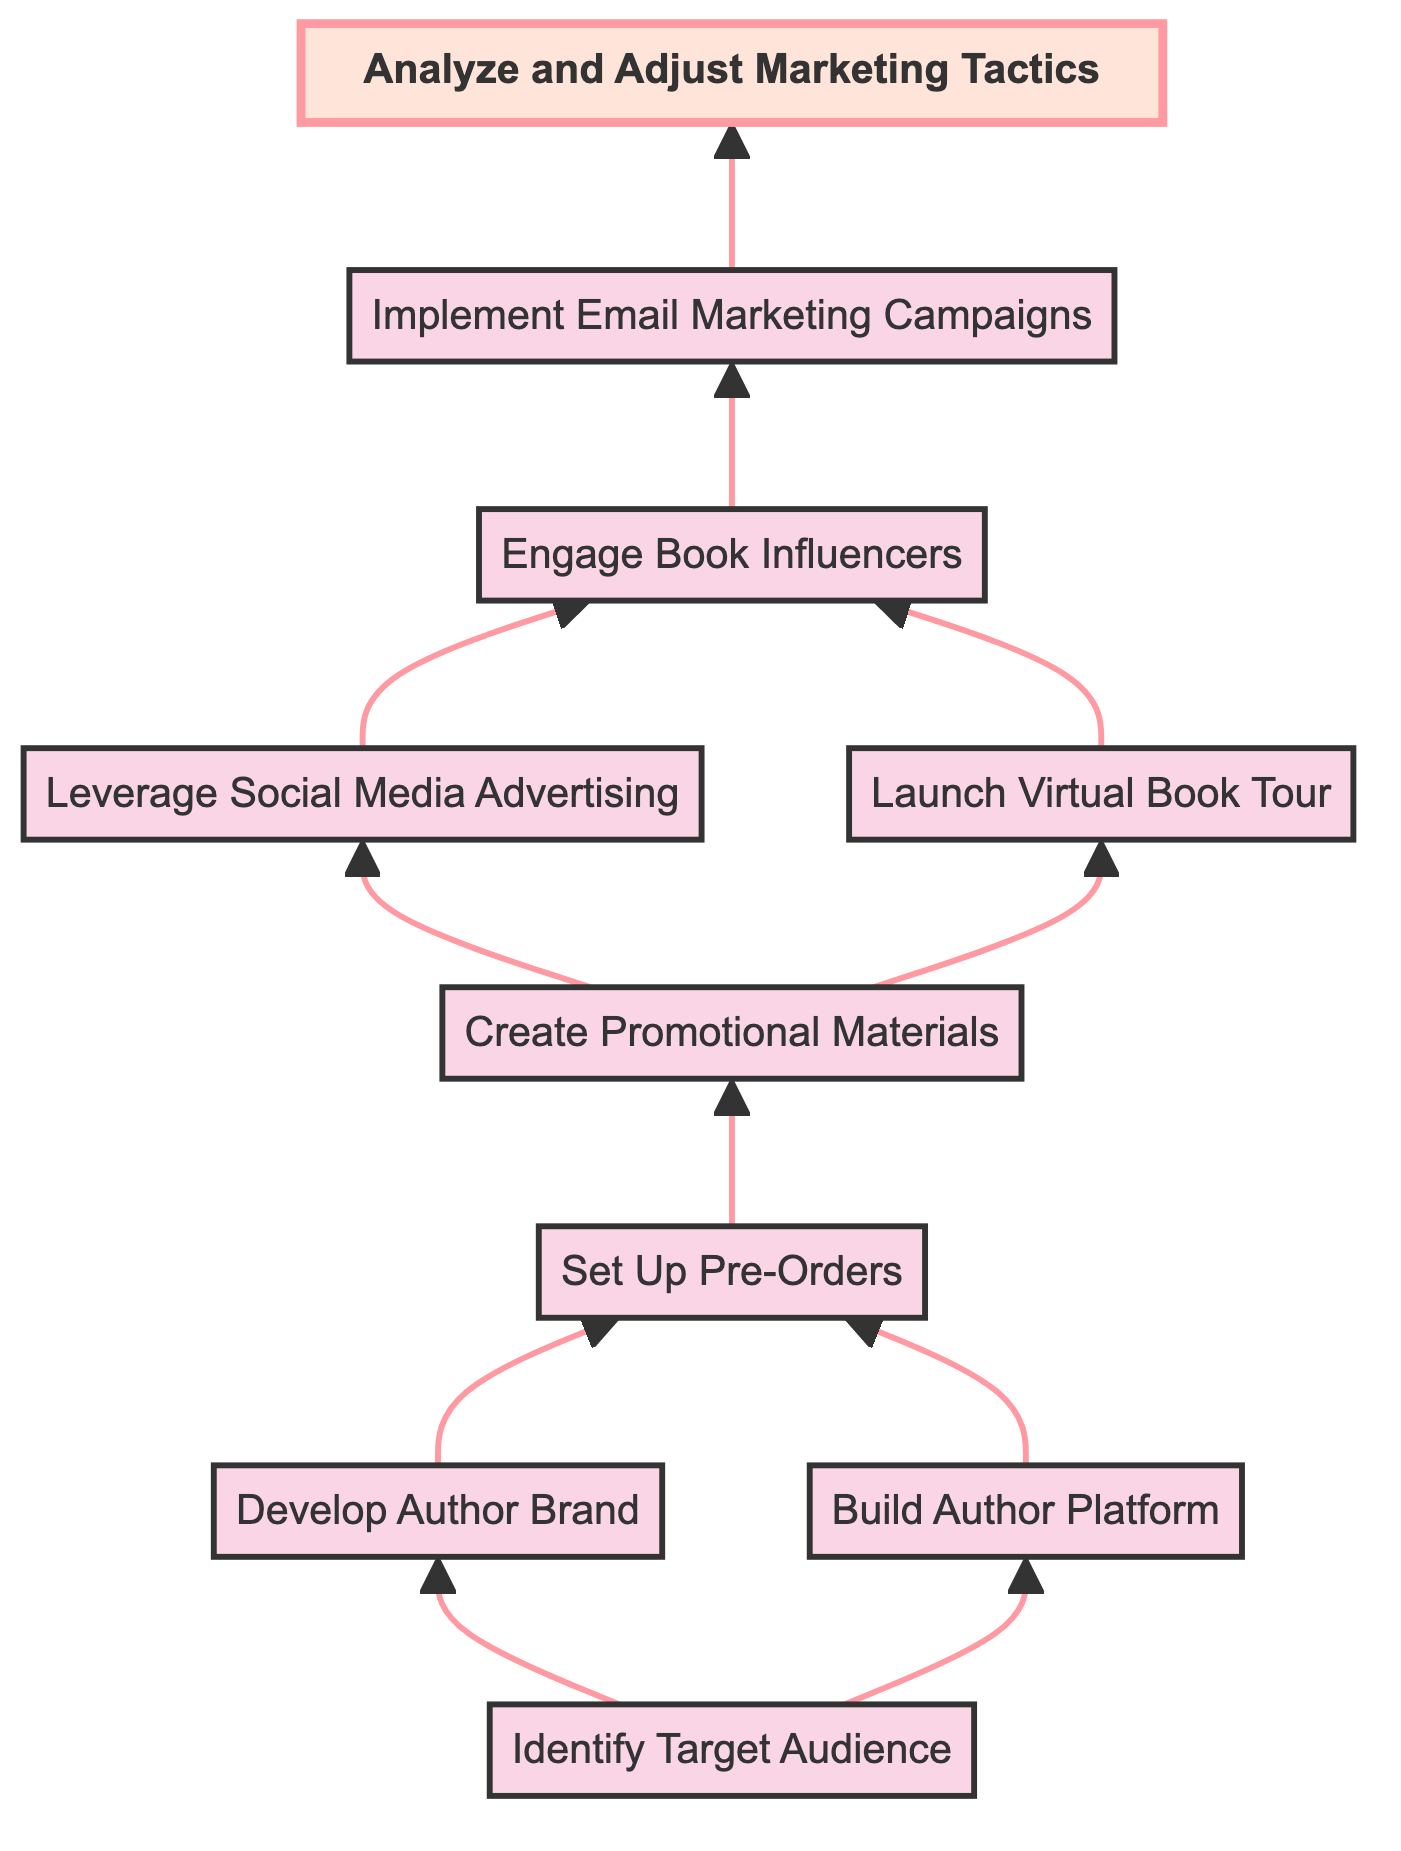What is the first step in the marketing strategy? The first step is "Identify Target Audience." This is the initial node in the diagram, showing it as the starting point for the marketing strategy process.
Answer: Identify Target Audience How many nodes are there in the flow chart? By counting each distinct step in the flow chart, we find there are a total of ten nodes from "Identify Target Audience" to "Analyze and Adjust Marketing Tactics."
Answer: 10 What follows after "Build Author Platform"? After "Build Author Platform," the next node is "Set Up Pre-Orders." This indicates that both "Develop Author Brand" and "Build Author Platform" lead into the same next step.
Answer: Set Up Pre-Orders Which promotional tactic is directly connected to "Create Promotional Materials"? "Leverage Social Media Advertising" and "Launch Virtual Book Tour" are both directly connected to "Create Promotional Materials," indicating both strategies build off this earlier step.
Answer: Leverage Social Media Advertising and Launch Virtual Book Tour What is the last step in the marketing strategy flow? The last step is "Analyze and Adjust Marketing Tactics." This ensures that the effectiveness of all previous strategies is reviewed and modified as needed.
Answer: Analyze and Adjust Marketing Tactics Which step involves engagement with readers prior to the book launch? The step that involves engagement with readers prior to the book launch is "Build Author Platform." This emphasizes the importance of establishing relationships early on.
Answer: Build Author Platform What is the relationship between "Engage Book Influencers" and "Implement Email Marketing Campaigns"? "Engage Book Influencers" leads directly into "Implement Email Marketing Campaigns," indicating that influencer engagement has a sequential role in the overall marketing strategy.
Answer: Sequential relationship Which medium is highlighted for advertising in the diagram? The highlighted mediums for advertising in the diagram are "Social Media," specifically targeting platforms like Facebook and Instagram.
Answer: Social Media In how many steps does the marketing strategy move from audience identification to analysis? The marketing strategy moves through a total of nine steps from "Identify Target Audience" to "Analyze and Adjust Marketing Tactics," forming a clear progression throughout the diagram.
Answer: 9 